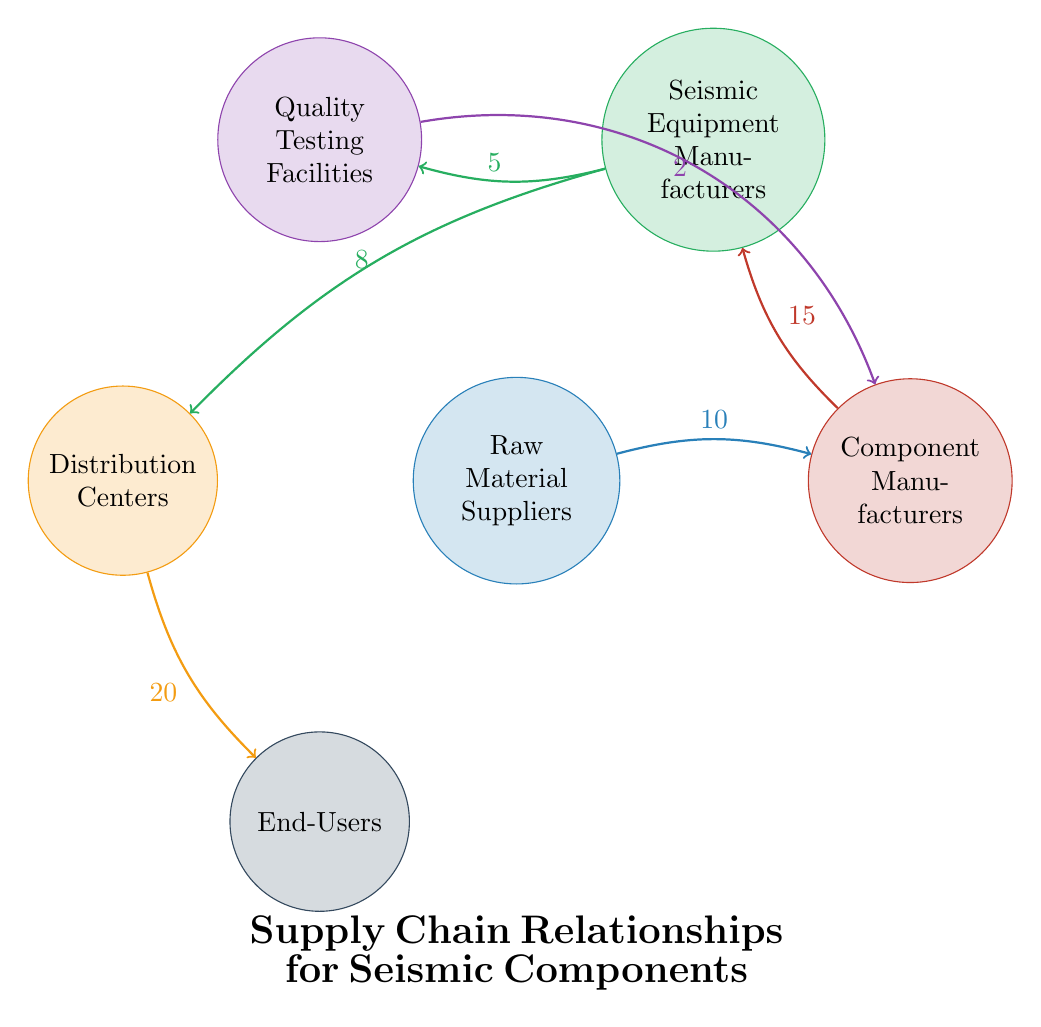What is the value of the connection between Raw Material Suppliers and Component Manufacturers? The diagram shows an arrow from Raw Material Suppliers to Component Manufacturers with a value label of 10 next to it, indicating the strength of the relationship.
Answer: 10 Which node has the strongest connection to End-Users? The diagram shows an arrow pointing from Distribution Centers to End-Users with a value of 20. This indicates that the Distribution Centers have the strongest connection to the End-Users compared to any other node.
Answer: Distribution Centers How many nodes are present in the diagram? The diagram identifies six distinct entities (nodes) in the supply chain: Raw Material Suppliers, Component Manufacturers, Seismic Equipment Manufacturers, Quality Testing Facilities, Distribution Centers, and End-Users.
Answer: 6 What is the value of the relationship between Seismic Equipment Manufacturers and Quality Testing Facilities? The diagram illustrates an arrow connecting Seismic Equipment Manufacturers to Quality Testing Facilities, marked with a value of 5, which indicates the strength of this particular relationship.
Answer: 5 Which two nodes have a direct relationship with Component Manufacturers? The diagram shows two arrows leading to/from Component Manufacturers: one from Raw Material Suppliers (value 10) and another from Quality Testing Facilities (value 2). This indicates that these are the two nodes that directly interact with Component Manufacturers.
Answer: Raw Material Suppliers and Quality Testing Facilities How does the relationship between Distribution Centers and End-Users compare to that of Component Manufacturers and Seismic Equipment Manufacturers? The relationship value from Distribution Centers to End-Users is 20, while the value from Component Manufacturers to Seismic Equipment Manufacturers is 15. This comparison indicates that the connection to End-Users is stronger than that to Seismic Equipment Manufacturers.
Answer: Stronger Which node provides quality testing to Component Manufacturers? The diagram indicates a connection from Quality Testing Facilities to Component Manufacturers, marked with a value of 2, indicating this relationship. Thus, Quality Testing Facilities are responsible for providing quality testing services.
Answer: Quality Testing Facilities What is the total flow value originating from Raw Material Suppliers? The value of the connection from Raw Material Suppliers to Component Manufacturers is 10, providing the total flow value originating from Raw Material Suppliers, as there are no other outgoing connections from this node.
Answer: 10 What is the cumulative value of connections leading to Seismic Equipment Manufacturers? The cumulative value of connections leading to Seismic Equipment Manufacturers includes 10 from Raw Material Suppliers and 15 from Component Manufacturers, totaling 25. Therefore, connections to Seismic Equipment Manufacturers entail the sum of these two values.
Answer: 25 